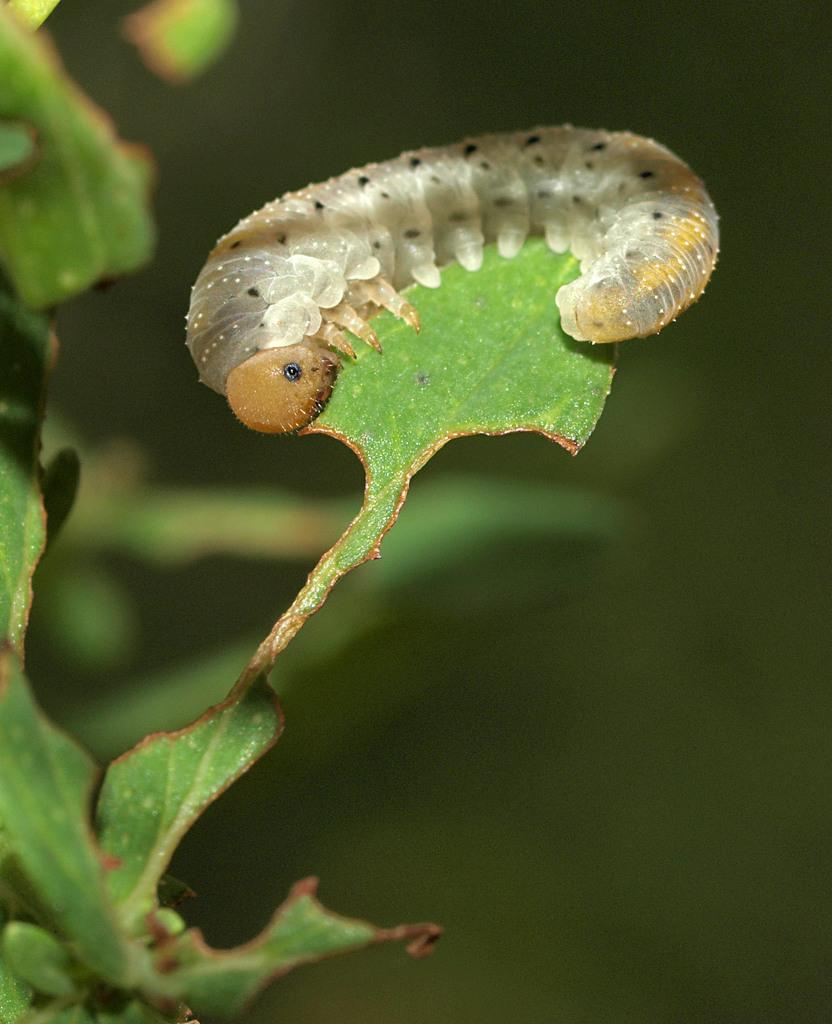What type of creature is on the plant in the image? There is a caterpillar on a plant in the image. Can you describe the background of the image? The background of the image is blurred. What type of animal is in the pocket of the person in the image? There is no person or pocket visible in the image; it only features a caterpillar on a plant with a blurred background. 